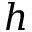<formula> <loc_0><loc_0><loc_500><loc_500>h</formula> 